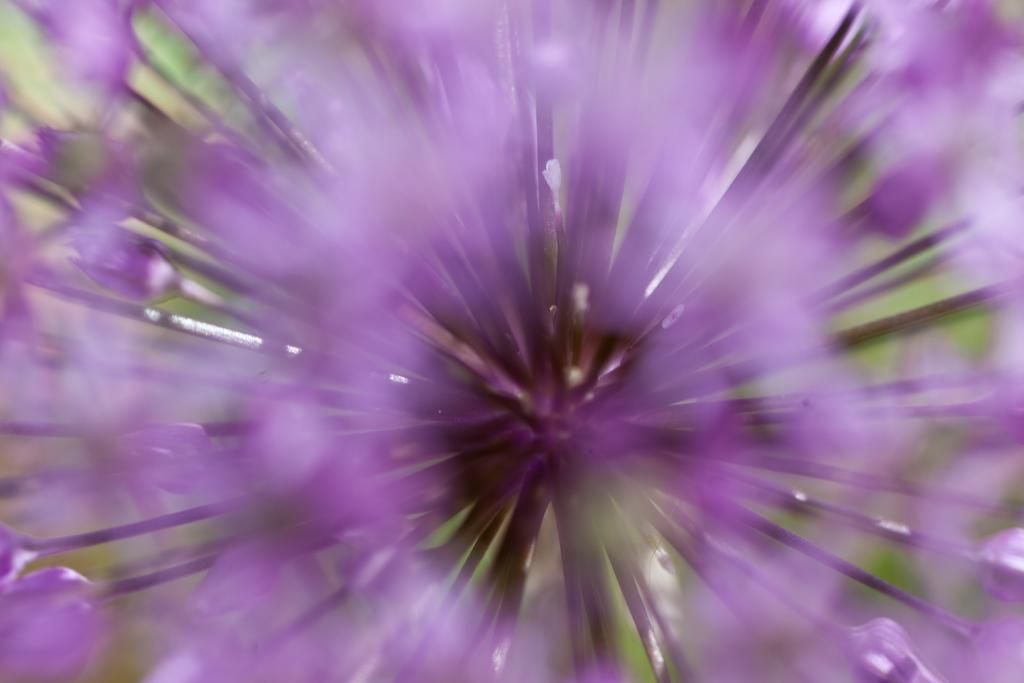What is the main subject of the image? The main subject of the image is a flower. Can you describe the flower in the image? The image contains a close-up view of a flower. What role does the actor play in the image? There is no actor present in the image, as it features a close-up view of a flower. How many arms can be seen reaching for the flower in the image? There are no arms visible in the image, as it features a close-up view of a flower. 